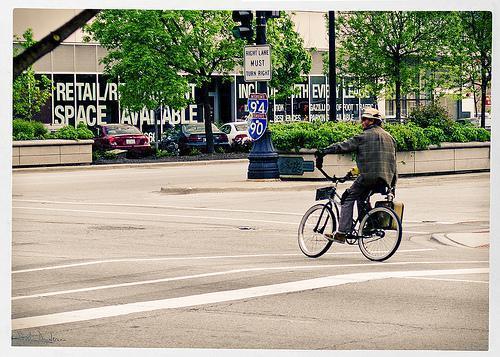How many cars are there?
Give a very brief answer. 3. How many interstate signs are in the image?
Give a very brief answer. 2. 